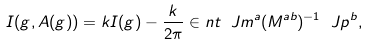Convert formula to latex. <formula><loc_0><loc_0><loc_500><loc_500>I ( g , A ( g ) ) = k I ( g ) - \frac { k } { 2 \pi } \in n t \ J m ^ { a } ( M ^ { a b } ) ^ { - 1 } \ J p ^ { b } ,</formula> 